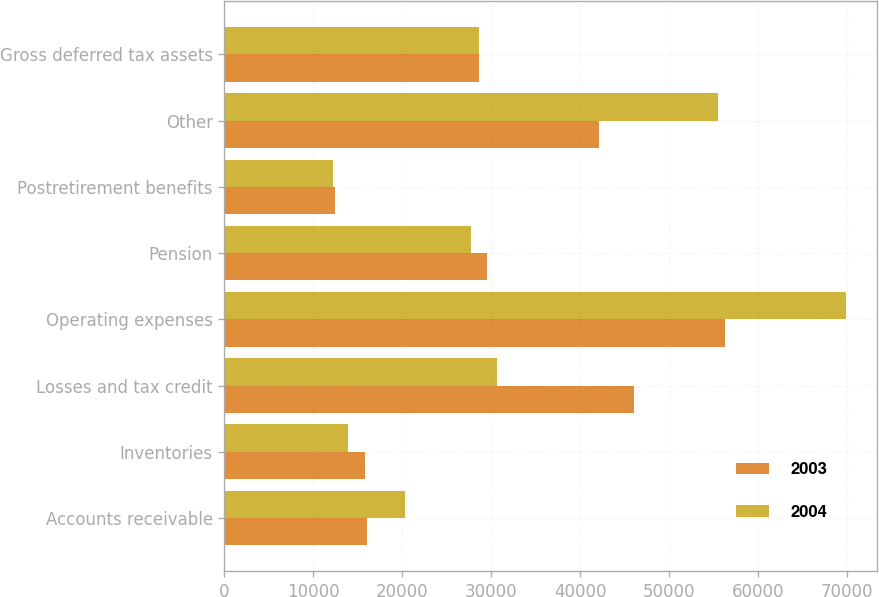<chart> <loc_0><loc_0><loc_500><loc_500><stacked_bar_chart><ecel><fcel>Accounts receivable<fcel>Inventories<fcel>Losses and tax credit<fcel>Operating expenses<fcel>Pension<fcel>Postretirement benefits<fcel>Other<fcel>Gross deferred tax assets<nl><fcel>2003<fcel>15997<fcel>15844<fcel>46018<fcel>56246<fcel>29496<fcel>12414<fcel>42127<fcel>28635.5<nl><fcel>2004<fcel>20248<fcel>13877<fcel>30626<fcel>69925<fcel>27775<fcel>12252<fcel>55460<fcel>28635.5<nl></chart> 